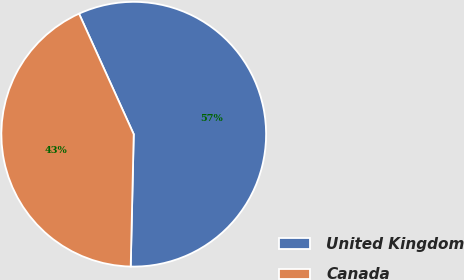Convert chart to OTSL. <chart><loc_0><loc_0><loc_500><loc_500><pie_chart><fcel>United Kingdom<fcel>Canada<nl><fcel>57.14%<fcel>42.86%<nl></chart> 